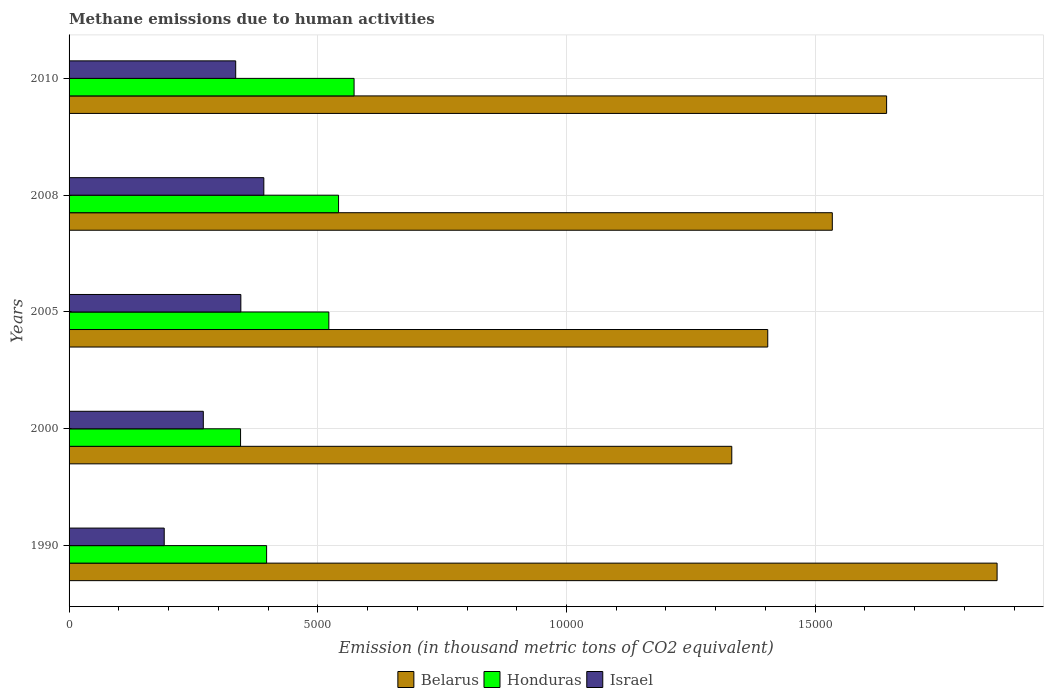How many different coloured bars are there?
Your answer should be very brief. 3. How many groups of bars are there?
Keep it short and to the point. 5. How many bars are there on the 1st tick from the bottom?
Ensure brevity in your answer.  3. What is the label of the 5th group of bars from the top?
Your answer should be very brief. 1990. What is the amount of methane emitted in Belarus in 2008?
Offer a very short reply. 1.53e+04. Across all years, what is the maximum amount of methane emitted in Belarus?
Your answer should be compact. 1.87e+04. Across all years, what is the minimum amount of methane emitted in Honduras?
Your response must be concise. 3447.7. What is the total amount of methane emitted in Honduras in the graph?
Your answer should be compact. 2.38e+04. What is the difference between the amount of methane emitted in Honduras in 1990 and that in 2010?
Your response must be concise. -1758.3. What is the difference between the amount of methane emitted in Israel in 1990 and the amount of methane emitted in Belarus in 2010?
Your answer should be compact. -1.45e+04. What is the average amount of methane emitted in Israel per year?
Provide a succinct answer. 3066.1. In the year 2005, what is the difference between the amount of methane emitted in Belarus and amount of methane emitted in Israel?
Make the answer very short. 1.06e+04. What is the ratio of the amount of methane emitted in Belarus in 2000 to that in 2008?
Provide a short and direct response. 0.87. Is the difference between the amount of methane emitted in Belarus in 1990 and 2000 greater than the difference between the amount of methane emitted in Israel in 1990 and 2000?
Provide a short and direct response. Yes. What is the difference between the highest and the second highest amount of methane emitted in Belarus?
Keep it short and to the point. 2221. What is the difference between the highest and the lowest amount of methane emitted in Israel?
Your answer should be very brief. 2002.3. In how many years, is the amount of methane emitted in Israel greater than the average amount of methane emitted in Israel taken over all years?
Ensure brevity in your answer.  3. Is the sum of the amount of methane emitted in Honduras in 2005 and 2010 greater than the maximum amount of methane emitted in Israel across all years?
Your response must be concise. Yes. What does the 2nd bar from the bottom in 2010 represents?
Your answer should be very brief. Honduras. How many bars are there?
Offer a terse response. 15. Where does the legend appear in the graph?
Provide a succinct answer. Bottom center. How many legend labels are there?
Offer a very short reply. 3. How are the legend labels stacked?
Make the answer very short. Horizontal. What is the title of the graph?
Make the answer very short. Methane emissions due to human activities. Does "American Samoa" appear as one of the legend labels in the graph?
Your answer should be very brief. No. What is the label or title of the X-axis?
Offer a very short reply. Emission (in thousand metric tons of CO2 equivalent). What is the label or title of the Y-axis?
Offer a terse response. Years. What is the Emission (in thousand metric tons of CO2 equivalent) in Belarus in 1990?
Offer a terse response. 1.87e+04. What is the Emission (in thousand metric tons of CO2 equivalent) of Honduras in 1990?
Offer a very short reply. 3971.4. What is the Emission (in thousand metric tons of CO2 equivalent) in Israel in 1990?
Offer a terse response. 1913. What is the Emission (in thousand metric tons of CO2 equivalent) of Belarus in 2000?
Your answer should be very brief. 1.33e+04. What is the Emission (in thousand metric tons of CO2 equivalent) of Honduras in 2000?
Give a very brief answer. 3447.7. What is the Emission (in thousand metric tons of CO2 equivalent) in Israel in 2000?
Offer a very short reply. 2698.8. What is the Emission (in thousand metric tons of CO2 equivalent) in Belarus in 2005?
Make the answer very short. 1.40e+04. What is the Emission (in thousand metric tons of CO2 equivalent) of Honduras in 2005?
Provide a succinct answer. 5222.6. What is the Emission (in thousand metric tons of CO2 equivalent) in Israel in 2005?
Provide a short and direct response. 3453.3. What is the Emission (in thousand metric tons of CO2 equivalent) of Belarus in 2008?
Give a very brief answer. 1.53e+04. What is the Emission (in thousand metric tons of CO2 equivalent) in Honduras in 2008?
Make the answer very short. 5418. What is the Emission (in thousand metric tons of CO2 equivalent) of Israel in 2008?
Give a very brief answer. 3915.3. What is the Emission (in thousand metric tons of CO2 equivalent) of Belarus in 2010?
Offer a terse response. 1.64e+04. What is the Emission (in thousand metric tons of CO2 equivalent) of Honduras in 2010?
Your response must be concise. 5729.7. What is the Emission (in thousand metric tons of CO2 equivalent) of Israel in 2010?
Offer a very short reply. 3350.1. Across all years, what is the maximum Emission (in thousand metric tons of CO2 equivalent) of Belarus?
Your answer should be compact. 1.87e+04. Across all years, what is the maximum Emission (in thousand metric tons of CO2 equivalent) in Honduras?
Your response must be concise. 5729.7. Across all years, what is the maximum Emission (in thousand metric tons of CO2 equivalent) of Israel?
Offer a terse response. 3915.3. Across all years, what is the minimum Emission (in thousand metric tons of CO2 equivalent) in Belarus?
Offer a very short reply. 1.33e+04. Across all years, what is the minimum Emission (in thousand metric tons of CO2 equivalent) in Honduras?
Offer a terse response. 3447.7. Across all years, what is the minimum Emission (in thousand metric tons of CO2 equivalent) of Israel?
Make the answer very short. 1913. What is the total Emission (in thousand metric tons of CO2 equivalent) of Belarus in the graph?
Provide a succinct answer. 7.78e+04. What is the total Emission (in thousand metric tons of CO2 equivalent) of Honduras in the graph?
Offer a very short reply. 2.38e+04. What is the total Emission (in thousand metric tons of CO2 equivalent) of Israel in the graph?
Give a very brief answer. 1.53e+04. What is the difference between the Emission (in thousand metric tons of CO2 equivalent) in Belarus in 1990 and that in 2000?
Give a very brief answer. 5333.7. What is the difference between the Emission (in thousand metric tons of CO2 equivalent) of Honduras in 1990 and that in 2000?
Your response must be concise. 523.7. What is the difference between the Emission (in thousand metric tons of CO2 equivalent) of Israel in 1990 and that in 2000?
Offer a terse response. -785.8. What is the difference between the Emission (in thousand metric tons of CO2 equivalent) of Belarus in 1990 and that in 2005?
Provide a succinct answer. 4610.7. What is the difference between the Emission (in thousand metric tons of CO2 equivalent) in Honduras in 1990 and that in 2005?
Your response must be concise. -1251.2. What is the difference between the Emission (in thousand metric tons of CO2 equivalent) of Israel in 1990 and that in 2005?
Provide a short and direct response. -1540.3. What is the difference between the Emission (in thousand metric tons of CO2 equivalent) of Belarus in 1990 and that in 2008?
Keep it short and to the point. 3312.9. What is the difference between the Emission (in thousand metric tons of CO2 equivalent) in Honduras in 1990 and that in 2008?
Your answer should be compact. -1446.6. What is the difference between the Emission (in thousand metric tons of CO2 equivalent) in Israel in 1990 and that in 2008?
Offer a very short reply. -2002.3. What is the difference between the Emission (in thousand metric tons of CO2 equivalent) in Belarus in 1990 and that in 2010?
Your response must be concise. 2221. What is the difference between the Emission (in thousand metric tons of CO2 equivalent) of Honduras in 1990 and that in 2010?
Give a very brief answer. -1758.3. What is the difference between the Emission (in thousand metric tons of CO2 equivalent) in Israel in 1990 and that in 2010?
Offer a very short reply. -1437.1. What is the difference between the Emission (in thousand metric tons of CO2 equivalent) of Belarus in 2000 and that in 2005?
Your answer should be very brief. -723. What is the difference between the Emission (in thousand metric tons of CO2 equivalent) in Honduras in 2000 and that in 2005?
Provide a short and direct response. -1774.9. What is the difference between the Emission (in thousand metric tons of CO2 equivalent) in Israel in 2000 and that in 2005?
Your response must be concise. -754.5. What is the difference between the Emission (in thousand metric tons of CO2 equivalent) in Belarus in 2000 and that in 2008?
Ensure brevity in your answer.  -2020.8. What is the difference between the Emission (in thousand metric tons of CO2 equivalent) in Honduras in 2000 and that in 2008?
Provide a short and direct response. -1970.3. What is the difference between the Emission (in thousand metric tons of CO2 equivalent) in Israel in 2000 and that in 2008?
Make the answer very short. -1216.5. What is the difference between the Emission (in thousand metric tons of CO2 equivalent) of Belarus in 2000 and that in 2010?
Your answer should be compact. -3112.7. What is the difference between the Emission (in thousand metric tons of CO2 equivalent) in Honduras in 2000 and that in 2010?
Provide a succinct answer. -2282. What is the difference between the Emission (in thousand metric tons of CO2 equivalent) in Israel in 2000 and that in 2010?
Keep it short and to the point. -651.3. What is the difference between the Emission (in thousand metric tons of CO2 equivalent) in Belarus in 2005 and that in 2008?
Ensure brevity in your answer.  -1297.8. What is the difference between the Emission (in thousand metric tons of CO2 equivalent) in Honduras in 2005 and that in 2008?
Give a very brief answer. -195.4. What is the difference between the Emission (in thousand metric tons of CO2 equivalent) in Israel in 2005 and that in 2008?
Offer a very short reply. -462. What is the difference between the Emission (in thousand metric tons of CO2 equivalent) of Belarus in 2005 and that in 2010?
Ensure brevity in your answer.  -2389.7. What is the difference between the Emission (in thousand metric tons of CO2 equivalent) in Honduras in 2005 and that in 2010?
Provide a succinct answer. -507.1. What is the difference between the Emission (in thousand metric tons of CO2 equivalent) in Israel in 2005 and that in 2010?
Provide a short and direct response. 103.2. What is the difference between the Emission (in thousand metric tons of CO2 equivalent) of Belarus in 2008 and that in 2010?
Make the answer very short. -1091.9. What is the difference between the Emission (in thousand metric tons of CO2 equivalent) of Honduras in 2008 and that in 2010?
Your answer should be very brief. -311.7. What is the difference between the Emission (in thousand metric tons of CO2 equivalent) of Israel in 2008 and that in 2010?
Keep it short and to the point. 565.2. What is the difference between the Emission (in thousand metric tons of CO2 equivalent) of Belarus in 1990 and the Emission (in thousand metric tons of CO2 equivalent) of Honduras in 2000?
Provide a succinct answer. 1.52e+04. What is the difference between the Emission (in thousand metric tons of CO2 equivalent) in Belarus in 1990 and the Emission (in thousand metric tons of CO2 equivalent) in Israel in 2000?
Provide a succinct answer. 1.60e+04. What is the difference between the Emission (in thousand metric tons of CO2 equivalent) in Honduras in 1990 and the Emission (in thousand metric tons of CO2 equivalent) in Israel in 2000?
Your answer should be very brief. 1272.6. What is the difference between the Emission (in thousand metric tons of CO2 equivalent) in Belarus in 1990 and the Emission (in thousand metric tons of CO2 equivalent) in Honduras in 2005?
Your response must be concise. 1.34e+04. What is the difference between the Emission (in thousand metric tons of CO2 equivalent) of Belarus in 1990 and the Emission (in thousand metric tons of CO2 equivalent) of Israel in 2005?
Your answer should be very brief. 1.52e+04. What is the difference between the Emission (in thousand metric tons of CO2 equivalent) of Honduras in 1990 and the Emission (in thousand metric tons of CO2 equivalent) of Israel in 2005?
Make the answer very short. 518.1. What is the difference between the Emission (in thousand metric tons of CO2 equivalent) of Belarus in 1990 and the Emission (in thousand metric tons of CO2 equivalent) of Honduras in 2008?
Your answer should be compact. 1.32e+04. What is the difference between the Emission (in thousand metric tons of CO2 equivalent) of Belarus in 1990 and the Emission (in thousand metric tons of CO2 equivalent) of Israel in 2008?
Provide a succinct answer. 1.47e+04. What is the difference between the Emission (in thousand metric tons of CO2 equivalent) of Honduras in 1990 and the Emission (in thousand metric tons of CO2 equivalent) of Israel in 2008?
Offer a very short reply. 56.1. What is the difference between the Emission (in thousand metric tons of CO2 equivalent) of Belarus in 1990 and the Emission (in thousand metric tons of CO2 equivalent) of Honduras in 2010?
Offer a very short reply. 1.29e+04. What is the difference between the Emission (in thousand metric tons of CO2 equivalent) in Belarus in 1990 and the Emission (in thousand metric tons of CO2 equivalent) in Israel in 2010?
Give a very brief answer. 1.53e+04. What is the difference between the Emission (in thousand metric tons of CO2 equivalent) in Honduras in 1990 and the Emission (in thousand metric tons of CO2 equivalent) in Israel in 2010?
Your answer should be very brief. 621.3. What is the difference between the Emission (in thousand metric tons of CO2 equivalent) in Belarus in 2000 and the Emission (in thousand metric tons of CO2 equivalent) in Honduras in 2005?
Offer a very short reply. 8100.8. What is the difference between the Emission (in thousand metric tons of CO2 equivalent) in Belarus in 2000 and the Emission (in thousand metric tons of CO2 equivalent) in Israel in 2005?
Offer a terse response. 9870.1. What is the difference between the Emission (in thousand metric tons of CO2 equivalent) in Honduras in 2000 and the Emission (in thousand metric tons of CO2 equivalent) in Israel in 2005?
Provide a short and direct response. -5.6. What is the difference between the Emission (in thousand metric tons of CO2 equivalent) in Belarus in 2000 and the Emission (in thousand metric tons of CO2 equivalent) in Honduras in 2008?
Offer a very short reply. 7905.4. What is the difference between the Emission (in thousand metric tons of CO2 equivalent) in Belarus in 2000 and the Emission (in thousand metric tons of CO2 equivalent) in Israel in 2008?
Your answer should be compact. 9408.1. What is the difference between the Emission (in thousand metric tons of CO2 equivalent) of Honduras in 2000 and the Emission (in thousand metric tons of CO2 equivalent) of Israel in 2008?
Your response must be concise. -467.6. What is the difference between the Emission (in thousand metric tons of CO2 equivalent) of Belarus in 2000 and the Emission (in thousand metric tons of CO2 equivalent) of Honduras in 2010?
Your response must be concise. 7593.7. What is the difference between the Emission (in thousand metric tons of CO2 equivalent) in Belarus in 2000 and the Emission (in thousand metric tons of CO2 equivalent) in Israel in 2010?
Provide a succinct answer. 9973.3. What is the difference between the Emission (in thousand metric tons of CO2 equivalent) in Honduras in 2000 and the Emission (in thousand metric tons of CO2 equivalent) in Israel in 2010?
Provide a succinct answer. 97.6. What is the difference between the Emission (in thousand metric tons of CO2 equivalent) of Belarus in 2005 and the Emission (in thousand metric tons of CO2 equivalent) of Honduras in 2008?
Ensure brevity in your answer.  8628.4. What is the difference between the Emission (in thousand metric tons of CO2 equivalent) in Belarus in 2005 and the Emission (in thousand metric tons of CO2 equivalent) in Israel in 2008?
Your answer should be very brief. 1.01e+04. What is the difference between the Emission (in thousand metric tons of CO2 equivalent) in Honduras in 2005 and the Emission (in thousand metric tons of CO2 equivalent) in Israel in 2008?
Your answer should be very brief. 1307.3. What is the difference between the Emission (in thousand metric tons of CO2 equivalent) in Belarus in 2005 and the Emission (in thousand metric tons of CO2 equivalent) in Honduras in 2010?
Provide a succinct answer. 8316.7. What is the difference between the Emission (in thousand metric tons of CO2 equivalent) of Belarus in 2005 and the Emission (in thousand metric tons of CO2 equivalent) of Israel in 2010?
Your answer should be very brief. 1.07e+04. What is the difference between the Emission (in thousand metric tons of CO2 equivalent) in Honduras in 2005 and the Emission (in thousand metric tons of CO2 equivalent) in Israel in 2010?
Your response must be concise. 1872.5. What is the difference between the Emission (in thousand metric tons of CO2 equivalent) of Belarus in 2008 and the Emission (in thousand metric tons of CO2 equivalent) of Honduras in 2010?
Offer a very short reply. 9614.5. What is the difference between the Emission (in thousand metric tons of CO2 equivalent) of Belarus in 2008 and the Emission (in thousand metric tons of CO2 equivalent) of Israel in 2010?
Give a very brief answer. 1.20e+04. What is the difference between the Emission (in thousand metric tons of CO2 equivalent) of Honduras in 2008 and the Emission (in thousand metric tons of CO2 equivalent) of Israel in 2010?
Provide a short and direct response. 2067.9. What is the average Emission (in thousand metric tons of CO2 equivalent) of Belarus per year?
Your answer should be very brief. 1.56e+04. What is the average Emission (in thousand metric tons of CO2 equivalent) of Honduras per year?
Ensure brevity in your answer.  4757.88. What is the average Emission (in thousand metric tons of CO2 equivalent) of Israel per year?
Ensure brevity in your answer.  3066.1. In the year 1990, what is the difference between the Emission (in thousand metric tons of CO2 equivalent) in Belarus and Emission (in thousand metric tons of CO2 equivalent) in Honduras?
Your response must be concise. 1.47e+04. In the year 1990, what is the difference between the Emission (in thousand metric tons of CO2 equivalent) in Belarus and Emission (in thousand metric tons of CO2 equivalent) in Israel?
Offer a terse response. 1.67e+04. In the year 1990, what is the difference between the Emission (in thousand metric tons of CO2 equivalent) of Honduras and Emission (in thousand metric tons of CO2 equivalent) of Israel?
Keep it short and to the point. 2058.4. In the year 2000, what is the difference between the Emission (in thousand metric tons of CO2 equivalent) of Belarus and Emission (in thousand metric tons of CO2 equivalent) of Honduras?
Your answer should be very brief. 9875.7. In the year 2000, what is the difference between the Emission (in thousand metric tons of CO2 equivalent) in Belarus and Emission (in thousand metric tons of CO2 equivalent) in Israel?
Offer a terse response. 1.06e+04. In the year 2000, what is the difference between the Emission (in thousand metric tons of CO2 equivalent) in Honduras and Emission (in thousand metric tons of CO2 equivalent) in Israel?
Keep it short and to the point. 748.9. In the year 2005, what is the difference between the Emission (in thousand metric tons of CO2 equivalent) in Belarus and Emission (in thousand metric tons of CO2 equivalent) in Honduras?
Provide a succinct answer. 8823.8. In the year 2005, what is the difference between the Emission (in thousand metric tons of CO2 equivalent) in Belarus and Emission (in thousand metric tons of CO2 equivalent) in Israel?
Offer a terse response. 1.06e+04. In the year 2005, what is the difference between the Emission (in thousand metric tons of CO2 equivalent) of Honduras and Emission (in thousand metric tons of CO2 equivalent) of Israel?
Make the answer very short. 1769.3. In the year 2008, what is the difference between the Emission (in thousand metric tons of CO2 equivalent) of Belarus and Emission (in thousand metric tons of CO2 equivalent) of Honduras?
Keep it short and to the point. 9926.2. In the year 2008, what is the difference between the Emission (in thousand metric tons of CO2 equivalent) of Belarus and Emission (in thousand metric tons of CO2 equivalent) of Israel?
Give a very brief answer. 1.14e+04. In the year 2008, what is the difference between the Emission (in thousand metric tons of CO2 equivalent) in Honduras and Emission (in thousand metric tons of CO2 equivalent) in Israel?
Offer a very short reply. 1502.7. In the year 2010, what is the difference between the Emission (in thousand metric tons of CO2 equivalent) in Belarus and Emission (in thousand metric tons of CO2 equivalent) in Honduras?
Your answer should be compact. 1.07e+04. In the year 2010, what is the difference between the Emission (in thousand metric tons of CO2 equivalent) of Belarus and Emission (in thousand metric tons of CO2 equivalent) of Israel?
Your answer should be very brief. 1.31e+04. In the year 2010, what is the difference between the Emission (in thousand metric tons of CO2 equivalent) of Honduras and Emission (in thousand metric tons of CO2 equivalent) of Israel?
Offer a very short reply. 2379.6. What is the ratio of the Emission (in thousand metric tons of CO2 equivalent) in Belarus in 1990 to that in 2000?
Provide a succinct answer. 1.4. What is the ratio of the Emission (in thousand metric tons of CO2 equivalent) in Honduras in 1990 to that in 2000?
Ensure brevity in your answer.  1.15. What is the ratio of the Emission (in thousand metric tons of CO2 equivalent) of Israel in 1990 to that in 2000?
Your response must be concise. 0.71. What is the ratio of the Emission (in thousand metric tons of CO2 equivalent) of Belarus in 1990 to that in 2005?
Your answer should be very brief. 1.33. What is the ratio of the Emission (in thousand metric tons of CO2 equivalent) of Honduras in 1990 to that in 2005?
Give a very brief answer. 0.76. What is the ratio of the Emission (in thousand metric tons of CO2 equivalent) of Israel in 1990 to that in 2005?
Provide a succinct answer. 0.55. What is the ratio of the Emission (in thousand metric tons of CO2 equivalent) of Belarus in 1990 to that in 2008?
Your response must be concise. 1.22. What is the ratio of the Emission (in thousand metric tons of CO2 equivalent) in Honduras in 1990 to that in 2008?
Give a very brief answer. 0.73. What is the ratio of the Emission (in thousand metric tons of CO2 equivalent) in Israel in 1990 to that in 2008?
Offer a very short reply. 0.49. What is the ratio of the Emission (in thousand metric tons of CO2 equivalent) in Belarus in 1990 to that in 2010?
Keep it short and to the point. 1.14. What is the ratio of the Emission (in thousand metric tons of CO2 equivalent) in Honduras in 1990 to that in 2010?
Offer a terse response. 0.69. What is the ratio of the Emission (in thousand metric tons of CO2 equivalent) of Israel in 1990 to that in 2010?
Make the answer very short. 0.57. What is the ratio of the Emission (in thousand metric tons of CO2 equivalent) of Belarus in 2000 to that in 2005?
Keep it short and to the point. 0.95. What is the ratio of the Emission (in thousand metric tons of CO2 equivalent) of Honduras in 2000 to that in 2005?
Your answer should be very brief. 0.66. What is the ratio of the Emission (in thousand metric tons of CO2 equivalent) in Israel in 2000 to that in 2005?
Your answer should be very brief. 0.78. What is the ratio of the Emission (in thousand metric tons of CO2 equivalent) in Belarus in 2000 to that in 2008?
Your answer should be compact. 0.87. What is the ratio of the Emission (in thousand metric tons of CO2 equivalent) of Honduras in 2000 to that in 2008?
Your answer should be very brief. 0.64. What is the ratio of the Emission (in thousand metric tons of CO2 equivalent) of Israel in 2000 to that in 2008?
Your answer should be compact. 0.69. What is the ratio of the Emission (in thousand metric tons of CO2 equivalent) in Belarus in 2000 to that in 2010?
Make the answer very short. 0.81. What is the ratio of the Emission (in thousand metric tons of CO2 equivalent) in Honduras in 2000 to that in 2010?
Provide a short and direct response. 0.6. What is the ratio of the Emission (in thousand metric tons of CO2 equivalent) of Israel in 2000 to that in 2010?
Provide a succinct answer. 0.81. What is the ratio of the Emission (in thousand metric tons of CO2 equivalent) in Belarus in 2005 to that in 2008?
Your answer should be compact. 0.92. What is the ratio of the Emission (in thousand metric tons of CO2 equivalent) of Honduras in 2005 to that in 2008?
Provide a short and direct response. 0.96. What is the ratio of the Emission (in thousand metric tons of CO2 equivalent) in Israel in 2005 to that in 2008?
Give a very brief answer. 0.88. What is the ratio of the Emission (in thousand metric tons of CO2 equivalent) of Belarus in 2005 to that in 2010?
Your response must be concise. 0.85. What is the ratio of the Emission (in thousand metric tons of CO2 equivalent) of Honduras in 2005 to that in 2010?
Make the answer very short. 0.91. What is the ratio of the Emission (in thousand metric tons of CO2 equivalent) of Israel in 2005 to that in 2010?
Give a very brief answer. 1.03. What is the ratio of the Emission (in thousand metric tons of CO2 equivalent) of Belarus in 2008 to that in 2010?
Give a very brief answer. 0.93. What is the ratio of the Emission (in thousand metric tons of CO2 equivalent) of Honduras in 2008 to that in 2010?
Provide a succinct answer. 0.95. What is the ratio of the Emission (in thousand metric tons of CO2 equivalent) in Israel in 2008 to that in 2010?
Your answer should be very brief. 1.17. What is the difference between the highest and the second highest Emission (in thousand metric tons of CO2 equivalent) in Belarus?
Make the answer very short. 2221. What is the difference between the highest and the second highest Emission (in thousand metric tons of CO2 equivalent) of Honduras?
Ensure brevity in your answer.  311.7. What is the difference between the highest and the second highest Emission (in thousand metric tons of CO2 equivalent) in Israel?
Offer a terse response. 462. What is the difference between the highest and the lowest Emission (in thousand metric tons of CO2 equivalent) of Belarus?
Provide a succinct answer. 5333.7. What is the difference between the highest and the lowest Emission (in thousand metric tons of CO2 equivalent) in Honduras?
Ensure brevity in your answer.  2282. What is the difference between the highest and the lowest Emission (in thousand metric tons of CO2 equivalent) in Israel?
Provide a short and direct response. 2002.3. 